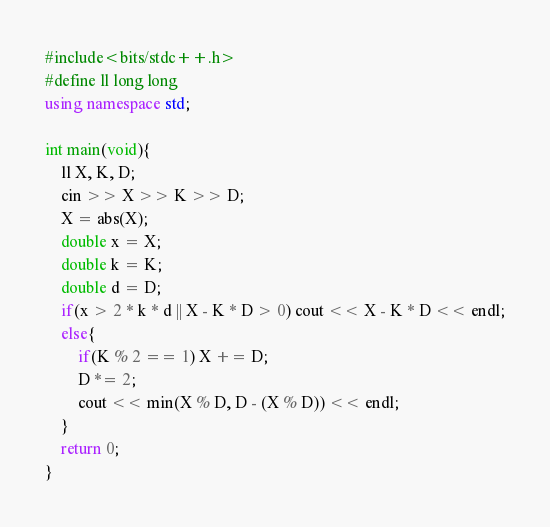<code> <loc_0><loc_0><loc_500><loc_500><_C++_>#include<bits/stdc++.h>
#define ll long long
using namespace std;

int main(void){
    ll X, K, D;
    cin >> X >> K >> D;
    X = abs(X);
    double x = X;
    double k = K;
    double d = D;
    if(x > 2 * k * d || X - K * D > 0) cout << X - K * D << endl;
    else{
        if(K % 2 == 1) X += D;
        D *= 2;
        cout << min(X % D, D - (X % D)) << endl;
    }
    return 0;
}
</code> 